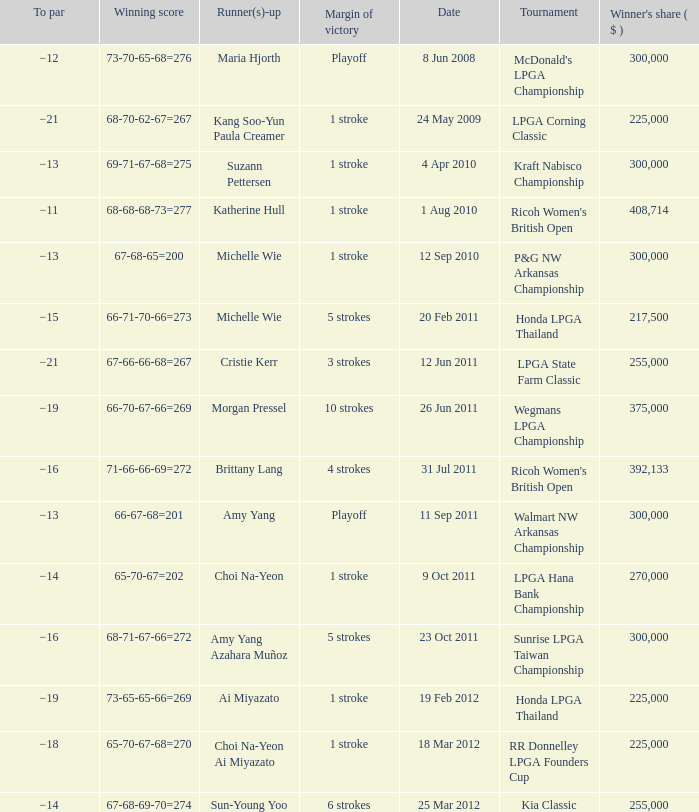Who was the runner-up in the RR Donnelley LPGA Founders Cup? Choi Na-Yeon Ai Miyazato. 